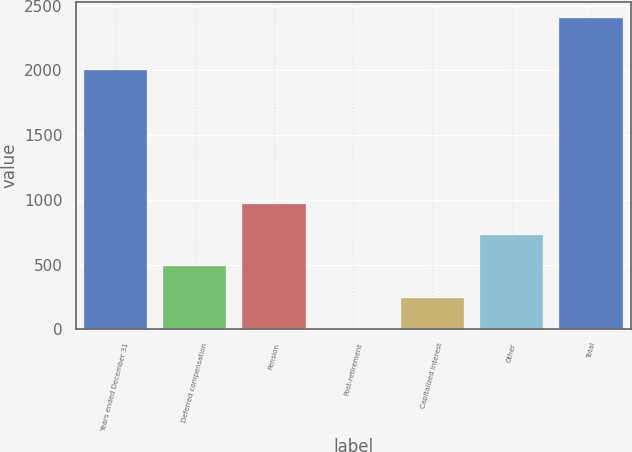Convert chart. <chart><loc_0><loc_0><loc_500><loc_500><bar_chart><fcel>Years ended December 31<fcel>Deferred compensation<fcel>Pension<fcel>Post-retirement<fcel>Capitalized interest<fcel>Other<fcel>Total<nl><fcel>2005<fcel>485.4<fcel>965.8<fcel>5<fcel>245.2<fcel>725.6<fcel>2407<nl></chart> 